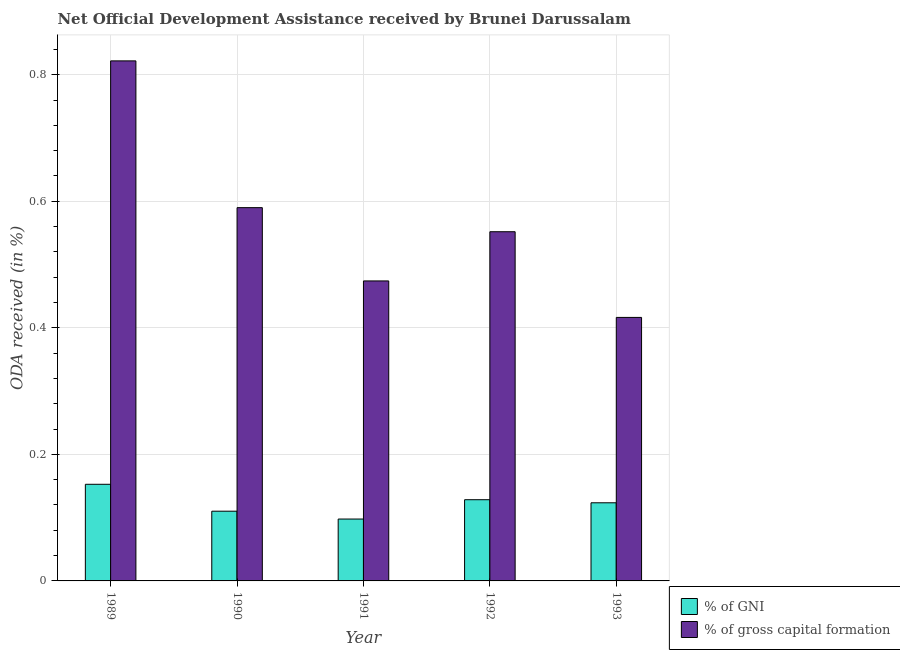How many different coloured bars are there?
Provide a short and direct response. 2. Are the number of bars per tick equal to the number of legend labels?
Provide a short and direct response. Yes. How many bars are there on the 1st tick from the left?
Your answer should be compact. 2. What is the label of the 4th group of bars from the left?
Your response must be concise. 1992. In how many cases, is the number of bars for a given year not equal to the number of legend labels?
Your response must be concise. 0. What is the oda received as percentage of gross capital formation in 1989?
Ensure brevity in your answer.  0.82. Across all years, what is the maximum oda received as percentage of gross capital formation?
Keep it short and to the point. 0.82. Across all years, what is the minimum oda received as percentage of gross capital formation?
Ensure brevity in your answer.  0.42. What is the total oda received as percentage of gni in the graph?
Your answer should be very brief. 0.61. What is the difference between the oda received as percentage of gross capital formation in 1989 and that in 1991?
Give a very brief answer. 0.35. What is the difference between the oda received as percentage of gross capital formation in 1989 and the oda received as percentage of gni in 1993?
Keep it short and to the point. 0.41. What is the average oda received as percentage of gni per year?
Keep it short and to the point. 0.12. What is the ratio of the oda received as percentage of gross capital formation in 1990 to that in 1991?
Keep it short and to the point. 1.24. Is the oda received as percentage of gross capital formation in 1990 less than that in 1991?
Ensure brevity in your answer.  No. What is the difference between the highest and the second highest oda received as percentage of gross capital formation?
Keep it short and to the point. 0.23. What is the difference between the highest and the lowest oda received as percentage of gni?
Provide a short and direct response. 0.05. Is the sum of the oda received as percentage of gross capital formation in 1990 and 1992 greater than the maximum oda received as percentage of gni across all years?
Offer a terse response. Yes. What does the 1st bar from the left in 1989 represents?
Keep it short and to the point. % of GNI. What does the 1st bar from the right in 1991 represents?
Offer a terse response. % of gross capital formation. How many bars are there?
Ensure brevity in your answer.  10. Does the graph contain any zero values?
Ensure brevity in your answer.  No. Does the graph contain grids?
Give a very brief answer. Yes. Where does the legend appear in the graph?
Ensure brevity in your answer.  Bottom right. How many legend labels are there?
Make the answer very short. 2. How are the legend labels stacked?
Offer a terse response. Vertical. What is the title of the graph?
Your response must be concise. Net Official Development Assistance received by Brunei Darussalam. What is the label or title of the X-axis?
Ensure brevity in your answer.  Year. What is the label or title of the Y-axis?
Your answer should be very brief. ODA received (in %). What is the ODA received (in %) in % of GNI in 1989?
Keep it short and to the point. 0.15. What is the ODA received (in %) in % of gross capital formation in 1989?
Provide a succinct answer. 0.82. What is the ODA received (in %) in % of GNI in 1990?
Your answer should be very brief. 0.11. What is the ODA received (in %) in % of gross capital formation in 1990?
Keep it short and to the point. 0.59. What is the ODA received (in %) of % of GNI in 1991?
Make the answer very short. 0.1. What is the ODA received (in %) of % of gross capital formation in 1991?
Ensure brevity in your answer.  0.47. What is the ODA received (in %) in % of GNI in 1992?
Provide a short and direct response. 0.13. What is the ODA received (in %) in % of gross capital formation in 1992?
Make the answer very short. 0.55. What is the ODA received (in %) of % of GNI in 1993?
Make the answer very short. 0.12. What is the ODA received (in %) of % of gross capital formation in 1993?
Ensure brevity in your answer.  0.42. Across all years, what is the maximum ODA received (in %) in % of GNI?
Offer a very short reply. 0.15. Across all years, what is the maximum ODA received (in %) in % of gross capital formation?
Provide a succinct answer. 0.82. Across all years, what is the minimum ODA received (in %) in % of GNI?
Offer a very short reply. 0.1. Across all years, what is the minimum ODA received (in %) in % of gross capital formation?
Give a very brief answer. 0.42. What is the total ODA received (in %) in % of GNI in the graph?
Ensure brevity in your answer.  0.61. What is the total ODA received (in %) in % of gross capital formation in the graph?
Keep it short and to the point. 2.85. What is the difference between the ODA received (in %) of % of GNI in 1989 and that in 1990?
Provide a succinct answer. 0.04. What is the difference between the ODA received (in %) in % of gross capital formation in 1989 and that in 1990?
Your answer should be compact. 0.23. What is the difference between the ODA received (in %) in % of GNI in 1989 and that in 1991?
Offer a terse response. 0.05. What is the difference between the ODA received (in %) in % of gross capital formation in 1989 and that in 1991?
Offer a terse response. 0.35. What is the difference between the ODA received (in %) in % of GNI in 1989 and that in 1992?
Your answer should be compact. 0.02. What is the difference between the ODA received (in %) in % of gross capital formation in 1989 and that in 1992?
Keep it short and to the point. 0.27. What is the difference between the ODA received (in %) of % of GNI in 1989 and that in 1993?
Offer a very short reply. 0.03. What is the difference between the ODA received (in %) of % of gross capital formation in 1989 and that in 1993?
Offer a very short reply. 0.41. What is the difference between the ODA received (in %) of % of GNI in 1990 and that in 1991?
Ensure brevity in your answer.  0.01. What is the difference between the ODA received (in %) of % of gross capital formation in 1990 and that in 1991?
Keep it short and to the point. 0.12. What is the difference between the ODA received (in %) of % of GNI in 1990 and that in 1992?
Offer a very short reply. -0.02. What is the difference between the ODA received (in %) of % of gross capital formation in 1990 and that in 1992?
Make the answer very short. 0.04. What is the difference between the ODA received (in %) in % of GNI in 1990 and that in 1993?
Provide a succinct answer. -0.01. What is the difference between the ODA received (in %) in % of gross capital formation in 1990 and that in 1993?
Your response must be concise. 0.17. What is the difference between the ODA received (in %) in % of GNI in 1991 and that in 1992?
Offer a very short reply. -0.03. What is the difference between the ODA received (in %) in % of gross capital formation in 1991 and that in 1992?
Offer a terse response. -0.08. What is the difference between the ODA received (in %) in % of GNI in 1991 and that in 1993?
Provide a succinct answer. -0.03. What is the difference between the ODA received (in %) of % of gross capital formation in 1991 and that in 1993?
Your response must be concise. 0.06. What is the difference between the ODA received (in %) of % of GNI in 1992 and that in 1993?
Provide a succinct answer. 0. What is the difference between the ODA received (in %) of % of gross capital formation in 1992 and that in 1993?
Make the answer very short. 0.14. What is the difference between the ODA received (in %) of % of GNI in 1989 and the ODA received (in %) of % of gross capital formation in 1990?
Provide a short and direct response. -0.44. What is the difference between the ODA received (in %) in % of GNI in 1989 and the ODA received (in %) in % of gross capital formation in 1991?
Keep it short and to the point. -0.32. What is the difference between the ODA received (in %) of % of GNI in 1989 and the ODA received (in %) of % of gross capital formation in 1992?
Ensure brevity in your answer.  -0.4. What is the difference between the ODA received (in %) in % of GNI in 1989 and the ODA received (in %) in % of gross capital formation in 1993?
Provide a succinct answer. -0.26. What is the difference between the ODA received (in %) in % of GNI in 1990 and the ODA received (in %) in % of gross capital formation in 1991?
Your answer should be very brief. -0.36. What is the difference between the ODA received (in %) in % of GNI in 1990 and the ODA received (in %) in % of gross capital formation in 1992?
Provide a succinct answer. -0.44. What is the difference between the ODA received (in %) in % of GNI in 1990 and the ODA received (in %) in % of gross capital formation in 1993?
Provide a short and direct response. -0.31. What is the difference between the ODA received (in %) in % of GNI in 1991 and the ODA received (in %) in % of gross capital formation in 1992?
Your answer should be compact. -0.45. What is the difference between the ODA received (in %) in % of GNI in 1991 and the ODA received (in %) in % of gross capital formation in 1993?
Offer a terse response. -0.32. What is the difference between the ODA received (in %) of % of GNI in 1992 and the ODA received (in %) of % of gross capital formation in 1993?
Offer a terse response. -0.29. What is the average ODA received (in %) of % of GNI per year?
Your response must be concise. 0.12. What is the average ODA received (in %) of % of gross capital formation per year?
Your response must be concise. 0.57. In the year 1989, what is the difference between the ODA received (in %) in % of GNI and ODA received (in %) in % of gross capital formation?
Your answer should be very brief. -0.67. In the year 1990, what is the difference between the ODA received (in %) in % of GNI and ODA received (in %) in % of gross capital formation?
Provide a short and direct response. -0.48. In the year 1991, what is the difference between the ODA received (in %) of % of GNI and ODA received (in %) of % of gross capital formation?
Ensure brevity in your answer.  -0.38. In the year 1992, what is the difference between the ODA received (in %) in % of GNI and ODA received (in %) in % of gross capital formation?
Your response must be concise. -0.42. In the year 1993, what is the difference between the ODA received (in %) in % of GNI and ODA received (in %) in % of gross capital formation?
Provide a succinct answer. -0.29. What is the ratio of the ODA received (in %) in % of GNI in 1989 to that in 1990?
Your answer should be compact. 1.39. What is the ratio of the ODA received (in %) of % of gross capital formation in 1989 to that in 1990?
Your response must be concise. 1.39. What is the ratio of the ODA received (in %) in % of GNI in 1989 to that in 1991?
Keep it short and to the point. 1.56. What is the ratio of the ODA received (in %) in % of gross capital formation in 1989 to that in 1991?
Offer a very short reply. 1.73. What is the ratio of the ODA received (in %) of % of GNI in 1989 to that in 1992?
Keep it short and to the point. 1.19. What is the ratio of the ODA received (in %) in % of gross capital formation in 1989 to that in 1992?
Your answer should be compact. 1.49. What is the ratio of the ODA received (in %) of % of GNI in 1989 to that in 1993?
Your answer should be compact. 1.24. What is the ratio of the ODA received (in %) of % of gross capital formation in 1989 to that in 1993?
Provide a short and direct response. 1.97. What is the ratio of the ODA received (in %) in % of GNI in 1990 to that in 1991?
Your response must be concise. 1.13. What is the ratio of the ODA received (in %) of % of gross capital formation in 1990 to that in 1991?
Make the answer very short. 1.24. What is the ratio of the ODA received (in %) in % of GNI in 1990 to that in 1992?
Provide a succinct answer. 0.86. What is the ratio of the ODA received (in %) in % of gross capital formation in 1990 to that in 1992?
Provide a short and direct response. 1.07. What is the ratio of the ODA received (in %) in % of GNI in 1990 to that in 1993?
Your response must be concise. 0.89. What is the ratio of the ODA received (in %) in % of gross capital formation in 1990 to that in 1993?
Make the answer very short. 1.42. What is the ratio of the ODA received (in %) in % of GNI in 1991 to that in 1992?
Provide a succinct answer. 0.76. What is the ratio of the ODA received (in %) in % of gross capital formation in 1991 to that in 1992?
Your answer should be compact. 0.86. What is the ratio of the ODA received (in %) in % of GNI in 1991 to that in 1993?
Your response must be concise. 0.79. What is the ratio of the ODA received (in %) in % of gross capital formation in 1991 to that in 1993?
Ensure brevity in your answer.  1.14. What is the ratio of the ODA received (in %) in % of GNI in 1992 to that in 1993?
Ensure brevity in your answer.  1.04. What is the ratio of the ODA received (in %) in % of gross capital formation in 1992 to that in 1993?
Provide a succinct answer. 1.33. What is the difference between the highest and the second highest ODA received (in %) of % of GNI?
Give a very brief answer. 0.02. What is the difference between the highest and the second highest ODA received (in %) of % of gross capital formation?
Give a very brief answer. 0.23. What is the difference between the highest and the lowest ODA received (in %) of % of GNI?
Provide a short and direct response. 0.05. What is the difference between the highest and the lowest ODA received (in %) in % of gross capital formation?
Your answer should be compact. 0.41. 